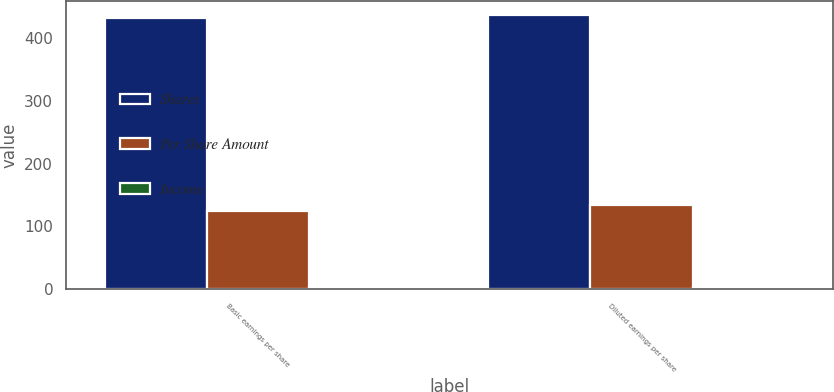<chart> <loc_0><loc_0><loc_500><loc_500><stacked_bar_chart><ecel><fcel>Basic earnings per share<fcel>Diluted earnings per share<nl><fcel>Shares<fcel>431.6<fcel>436.9<nl><fcel>Per Share Amount<fcel>124.1<fcel>134.7<nl><fcel>Income<fcel>3.48<fcel>3.24<nl></chart> 